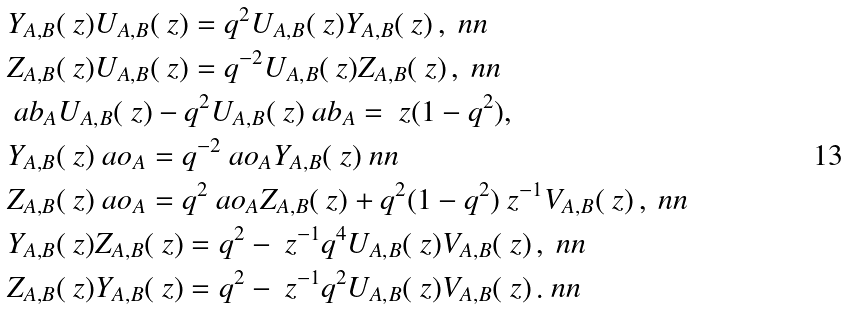<formula> <loc_0><loc_0><loc_500><loc_500>& Y _ { A , B } ( \ z ) U _ { A , B } ( \ z ) = q ^ { 2 } U _ { A , B } ( \ z ) Y _ { A , B } ( \ z ) \, , \ n n \\ & Z _ { A , B } ( \ z ) U _ { A , B } ( \ z ) = q ^ { - 2 } U _ { A , B } ( \ z ) Z _ { A , B } ( \ z ) \, , \ n n \\ & \ a b _ { A } U _ { A , B } ( \ z ) - q ^ { 2 } U _ { A , B } ( \ z ) \ a b _ { A } = \ z ( 1 - q ^ { 2 } ) , \\ & Y _ { A , B } ( \ z ) \ a o _ { A } = q ^ { - 2 } \ a o _ { A } Y _ { A , B } ( \ z ) \ n n \\ & Z _ { A , B } ( \ z ) \ a o _ { A } = q ^ { 2 } \ a o _ { A } Z _ { A , B } ( \ z ) + q ^ { 2 } ( 1 - q ^ { 2 } ) \ z ^ { - 1 } V _ { A , B } ( \ z ) \, , \ n n \\ & Y _ { A , B } ( \ z ) Z _ { A , B } ( \ z ) = q ^ { 2 } - \ z ^ { - 1 } q ^ { 4 } U _ { A , B } ( \ z ) V _ { A , B } ( \ z ) \, , \ n n \\ & Z _ { A , B } ( \ z ) Y _ { A , B } ( \ z ) = q ^ { 2 } - \ z ^ { - 1 } q ^ { 2 } U _ { A , B } ( \ z ) V _ { A , B } ( \ z ) \, . \ n n</formula> 